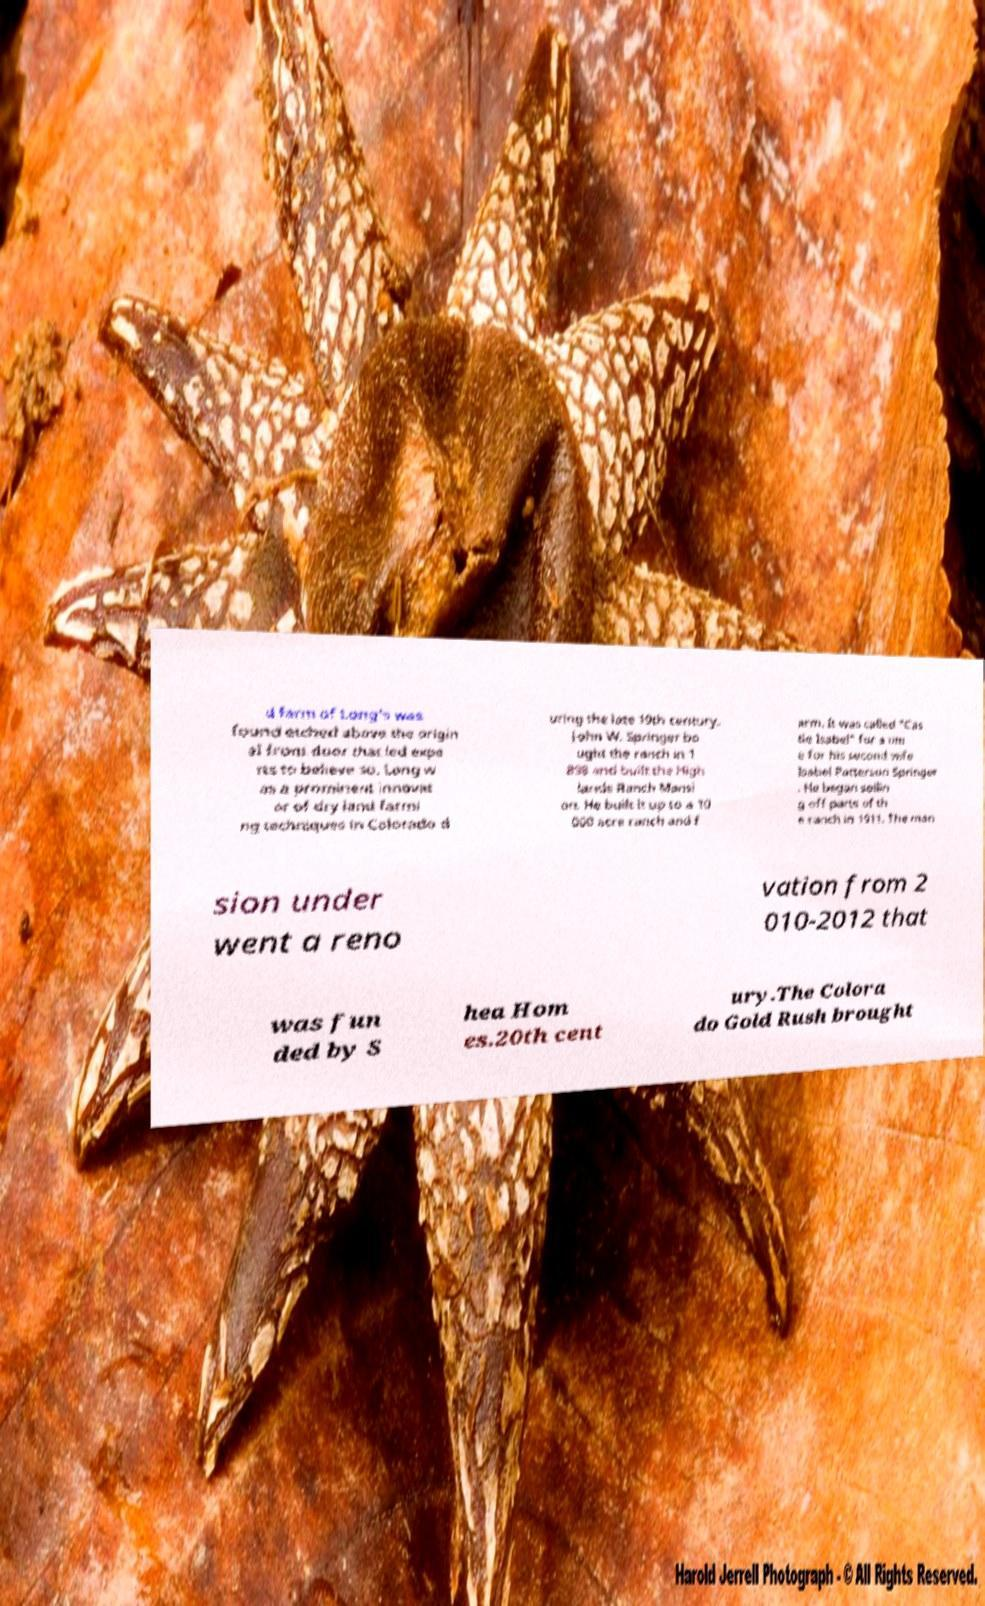What messages or text are displayed in this image? I need them in a readable, typed format. d farm of Long's was found etched above the origin al front door that led expe rts to believe so. Long w as a prominent innovat or of dry land farmi ng techniques in Colorado d uring the late 19th century. John W. Springer bo ught the ranch in 1 898 and built the High lands Ranch Mansi on. He built it up to a 10 000 acre ranch and f arm. It was called "Cas tle Isabel" for a tim e for his second wife Isabel Patterson Springer . He began sellin g off parts of th e ranch in 1911. The man sion under went a reno vation from 2 010-2012 that was fun ded by S hea Hom es.20th cent ury.The Colora do Gold Rush brought 